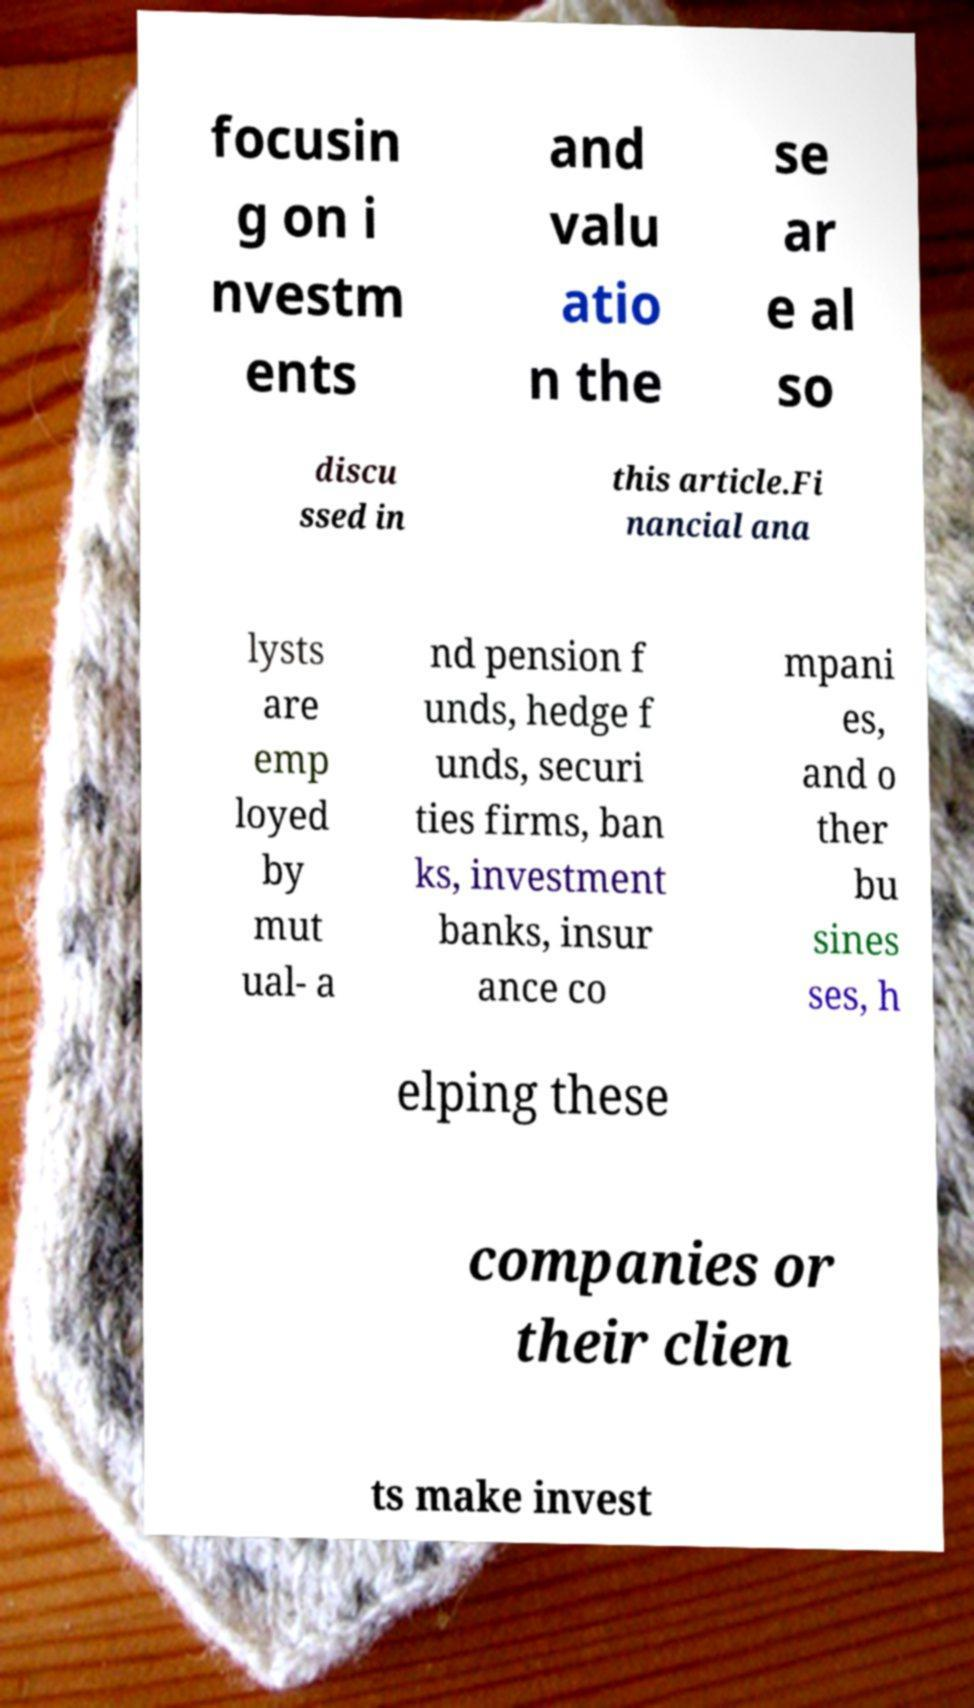Please identify and transcribe the text found in this image. focusin g on i nvestm ents and valu atio n the se ar e al so discu ssed in this article.Fi nancial ana lysts are emp loyed by mut ual- a nd pension f unds, hedge f unds, securi ties firms, ban ks, investment banks, insur ance co mpani es, and o ther bu sines ses, h elping these companies or their clien ts make invest 